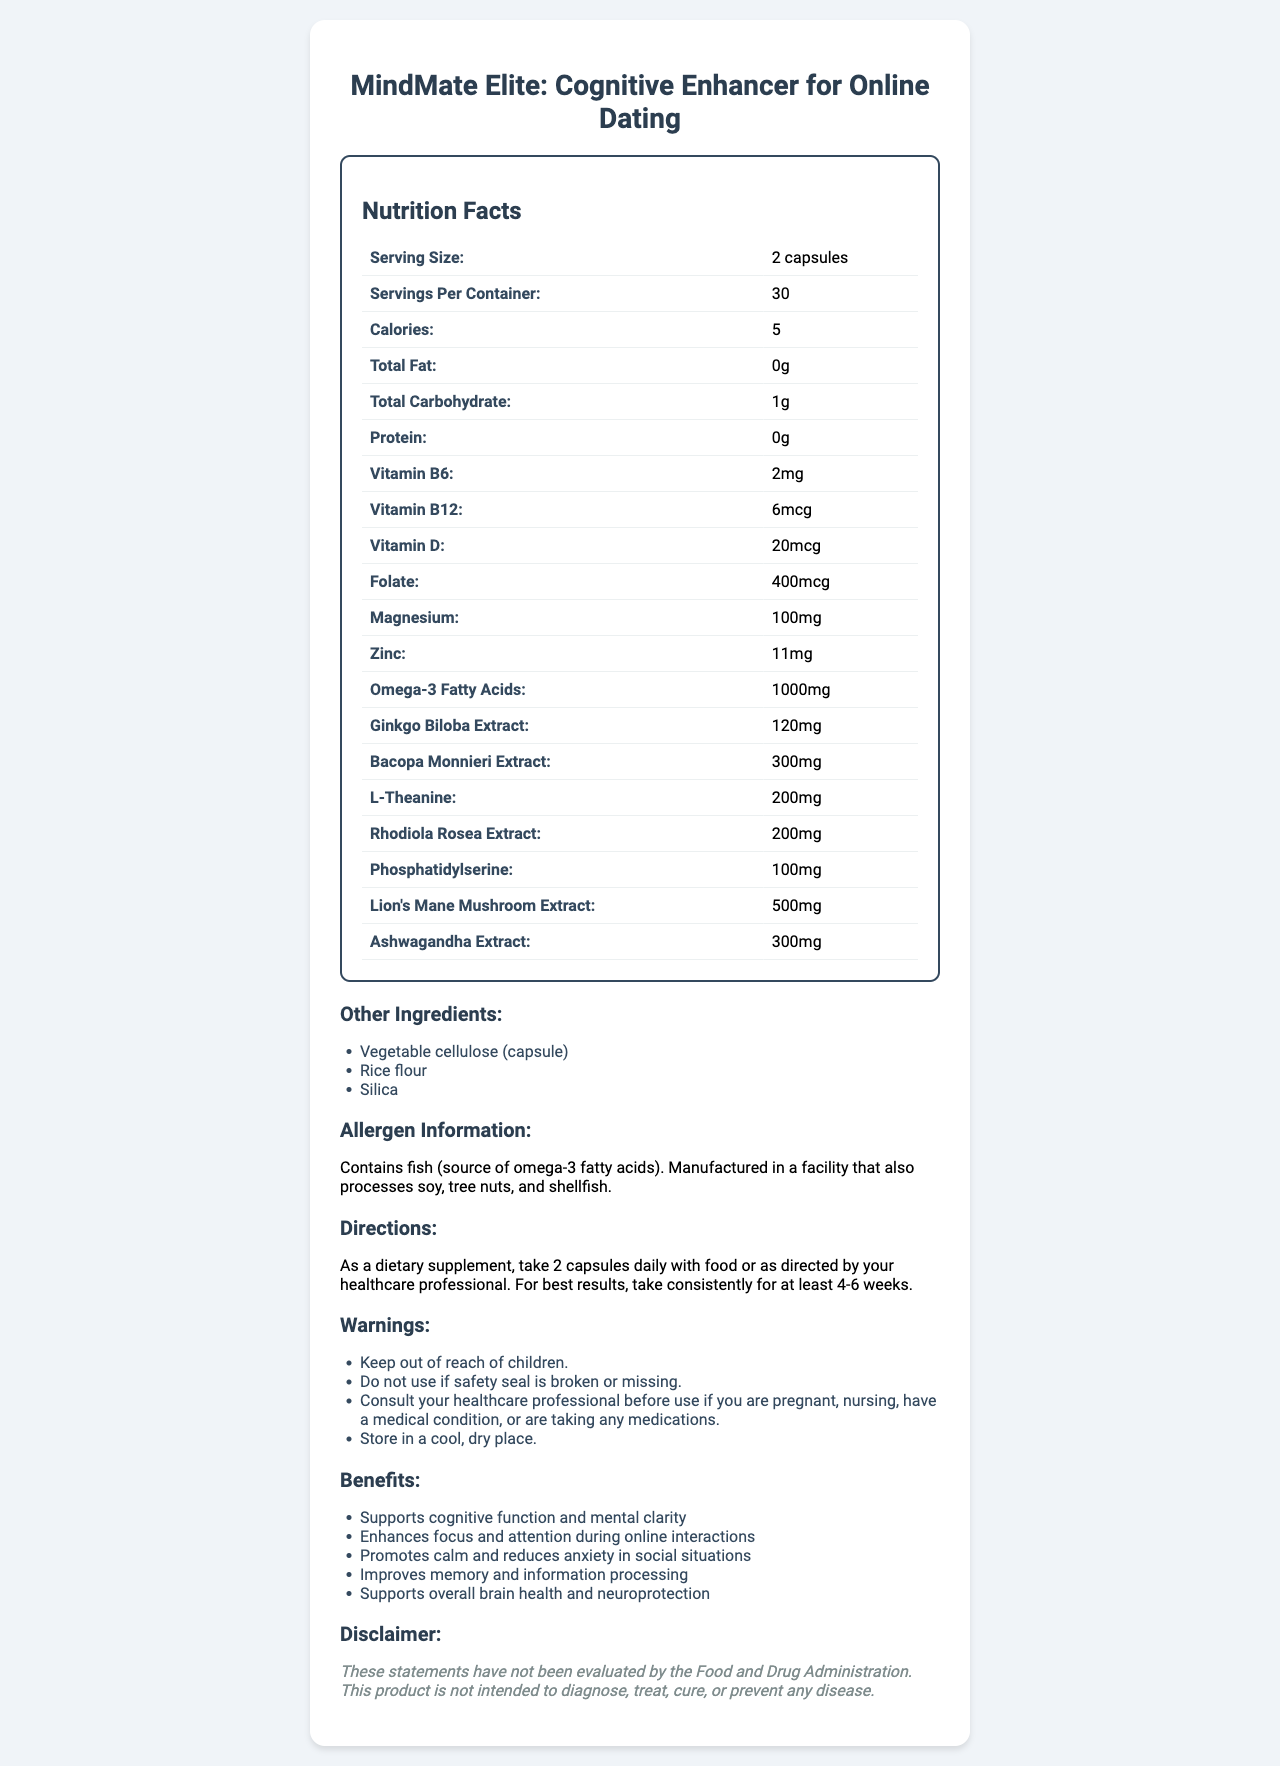what is the serving size for MindMate Elite? The serving size is listed at the top of the nutrition facts table as "Serving Size: 2 capsules."
Answer: 2 capsules how many calories are in each serving of MindMate Elite? The document indicates "Calories: 5" in the nutrition facts section.
Answer: 5 what is the amount of omega-3 fatty acids per serving? The nutrition facts label lists "Omega-3 Fatty Acids: 1000mg."
Answer: 1000mg which vitamin has the highest amount per serving in MindMate Elite? A. Vitamin B6 B. Vitamin B12 C. Vitamin D D. Folate The nutrients listed in the nutrition facts show "Vitamin D: 20mcg," which is higher compared to Vitamin B6 (2mg), Vitamin B12 (6mcg), and Folate (400mcg).
Answer: C. Vitamin D how many servings are there in each container of MindMate Elite? The nutrition facts section indicates "Servings Per Container: 30."
Answer: 30 does MindMate Elite contain any protein? The nutrition facts table shows "Protein: 0g," indicating there is no protein.
Answer: No what are the three main ingredients in the capsules aside from active ingredients? The other ingredients section lists "Vegetable cellulose (capsule)," "Rice flour," and "Silica."
Answer: Vegetable cellulose (capsule), Rice flour, Silica what is a potential allergen in MindMate Elite? The allergen information section states "Contains fish (source of omega-3 fatty acids)."
Answer: Fish how often should you take MindMate Elite for the best results? The directions section advises taking 2 capsules daily for best results, consistently for at least 4-6 weeks.
Answer: Daily for at least 4-6 weeks is MindMate Elite suitable for vegans? The allergen information mentions that the product contains fish, which is not suitable for vegans.
Answer: No which ingredient in MindMate Elite is primarily known for stress relief and reducing anxiety? A. Ginkgo Biloba Extract B. Bacopa Monnieri Extract C. L-Theanine D. Ashwagandha Extract Ashwagandha is commonly known for its stress-relieving and anxiety-reducing properties, and the document lists "Ashwagandha Extract: 300mg."
Answer: D. Ashwagandha Extract summarize the benefits provided by MindMate Elite. The benefits section lists the specific advantages of using MindMate Elite, such as supporting cognitive function, enhancing focus, promoting calm, improving memory, and supporting brain health.
Answer: MindMate Elite supports cognitive function and mental clarity, enhances focus and attention during online interactions, promotes calm and reduces anxiety in social situations, improves memory and information processing, and supports overall brain health and neuroprotection. what should you do if the safety seal is broken or missing? The warnings section advises against using the product if the safety seal is broken or missing.
Answer: Do not use the product. how much L-Theanine is in each serving of MindMate Elite? The nutrition facts state "L-Theanine: 200mg."
Answer: 200mg how much ginkgo biloba extract is included in each serving? The document lists "Ginkgo Biloba Extract: 120mg" in the nutrition facts.
Answer: 120mg which of the following cannot be determined from the document? A. The exact price of MindMate Elite B. The amount of rice flour in each capsule C. Whether the capsules are flavored D. All of the above The document does not provide information on the exact price, the specific amount of rice flour, or whether the capsules are flavored.
Answer: D. All of the above 